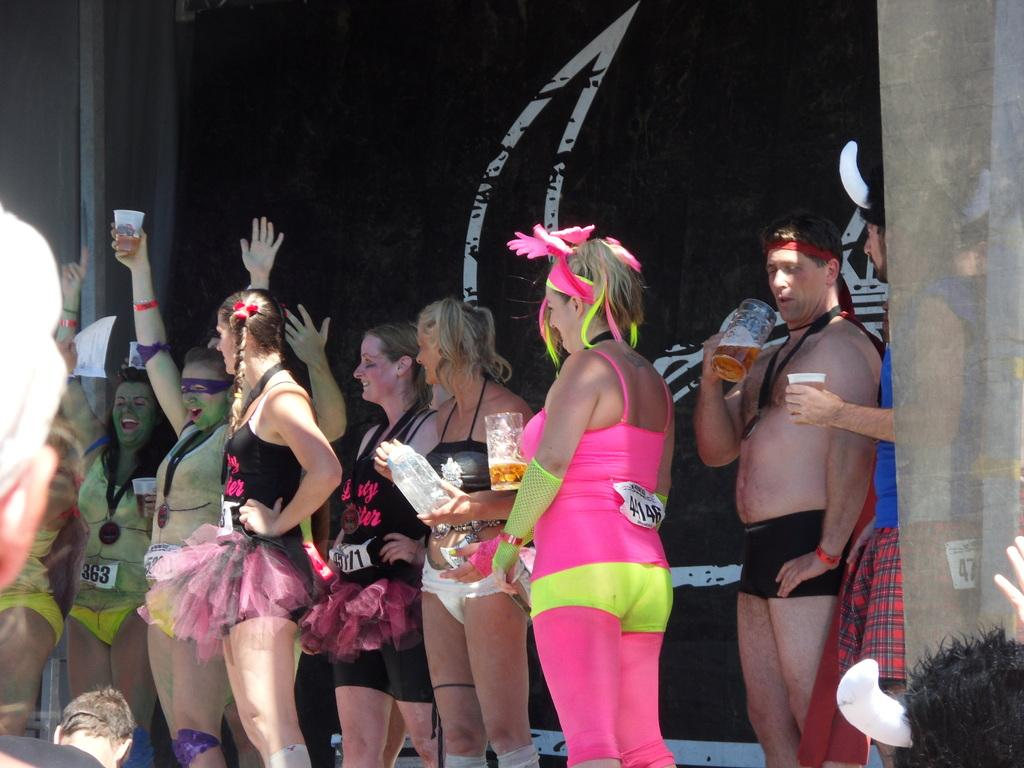What is the main subject of the image? The main subject of the image is people. Can you describe the appearance of the people in the image? The people appear to be wearing costumes. What can be seen in the background of the image? There is a curtain in the background of the image. What architectural feature is present on the right side of the image? There is a wooden pillar on the right side of the image. What type of veil can be seen on the people in the image? There is no veil present on the people in the image; they are wearing costumes. What year does the image depict? The image does not provide any information about the year it depicts. 